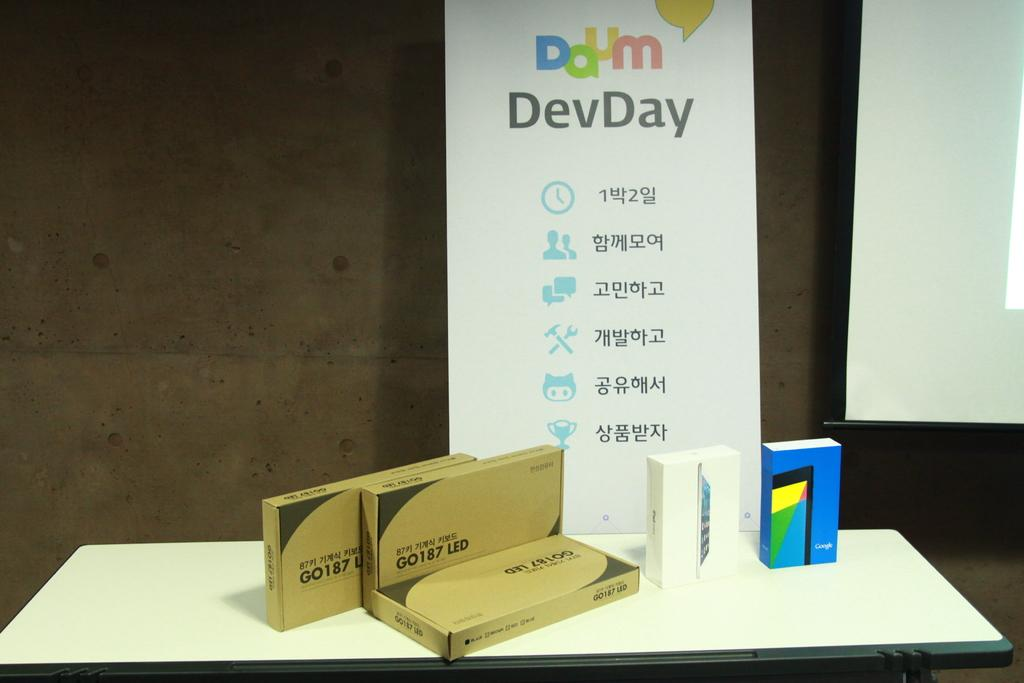<image>
Offer a succinct explanation of the picture presented. 3 boxes of GO 187 LED in front of a DevDay sign. 